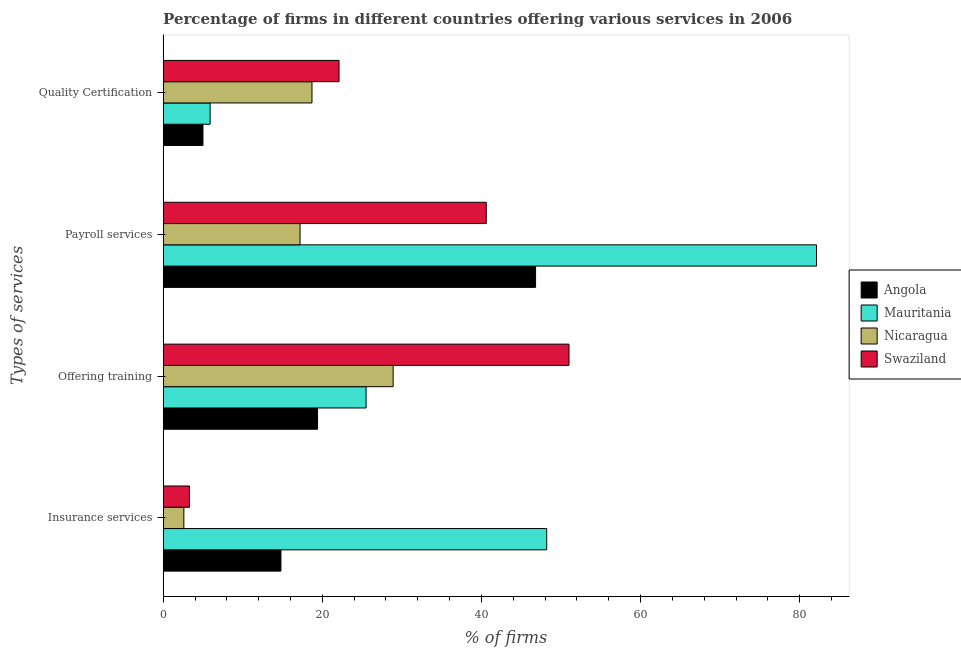How many different coloured bars are there?
Offer a terse response. 4. How many groups of bars are there?
Your answer should be very brief. 4. Are the number of bars per tick equal to the number of legend labels?
Provide a short and direct response. Yes. Are the number of bars on each tick of the Y-axis equal?
Provide a succinct answer. Yes. What is the label of the 1st group of bars from the top?
Keep it short and to the point. Quality Certification. What is the percentage of firms offering quality certification in Nicaragua?
Your answer should be very brief. 18.7. Across all countries, what is the maximum percentage of firms offering quality certification?
Provide a short and direct response. 22.1. In which country was the percentage of firms offering quality certification maximum?
Provide a short and direct response. Swaziland. In which country was the percentage of firms offering insurance services minimum?
Keep it short and to the point. Nicaragua. What is the total percentage of firms offering training in the graph?
Your response must be concise. 124.8. What is the difference between the percentage of firms offering payroll services in Angola and that in Nicaragua?
Your answer should be compact. 29.6. What is the difference between the percentage of firms offering training in Swaziland and the percentage of firms offering insurance services in Nicaragua?
Offer a terse response. 48.4. What is the average percentage of firms offering payroll services per country?
Provide a succinct answer. 46.67. What is the difference between the percentage of firms offering quality certification and percentage of firms offering payroll services in Angola?
Your answer should be very brief. -41.8. In how many countries, is the percentage of firms offering payroll services greater than 48 %?
Offer a very short reply. 1. What is the ratio of the percentage of firms offering payroll services in Mauritania to that in Nicaragua?
Offer a terse response. 4.77. What is the difference between the highest and the second highest percentage of firms offering training?
Offer a terse response. 22.1. In how many countries, is the percentage of firms offering payroll services greater than the average percentage of firms offering payroll services taken over all countries?
Provide a succinct answer. 2. Is the sum of the percentage of firms offering training in Mauritania and Angola greater than the maximum percentage of firms offering payroll services across all countries?
Provide a succinct answer. No. Is it the case that in every country, the sum of the percentage of firms offering payroll services and percentage of firms offering insurance services is greater than the sum of percentage of firms offering quality certification and percentage of firms offering training?
Offer a very short reply. No. What does the 1st bar from the top in Payroll services represents?
Ensure brevity in your answer.  Swaziland. What does the 4th bar from the bottom in Offering training represents?
Offer a very short reply. Swaziland. How many bars are there?
Provide a short and direct response. 16. How many countries are there in the graph?
Ensure brevity in your answer.  4. What is the difference between two consecutive major ticks on the X-axis?
Give a very brief answer. 20. Are the values on the major ticks of X-axis written in scientific E-notation?
Make the answer very short. No. Does the graph contain grids?
Your answer should be very brief. No. How many legend labels are there?
Provide a short and direct response. 4. How are the legend labels stacked?
Give a very brief answer. Vertical. What is the title of the graph?
Make the answer very short. Percentage of firms in different countries offering various services in 2006. Does "Croatia" appear as one of the legend labels in the graph?
Your answer should be compact. No. What is the label or title of the X-axis?
Your answer should be compact. % of firms. What is the label or title of the Y-axis?
Provide a short and direct response. Types of services. What is the % of firms of Mauritania in Insurance services?
Keep it short and to the point. 48.2. What is the % of firms in Swaziland in Insurance services?
Make the answer very short. 3.3. What is the % of firms of Angola in Offering training?
Give a very brief answer. 19.4. What is the % of firms in Nicaragua in Offering training?
Your answer should be very brief. 28.9. What is the % of firms in Swaziland in Offering training?
Provide a short and direct response. 51. What is the % of firms in Angola in Payroll services?
Offer a very short reply. 46.8. What is the % of firms in Mauritania in Payroll services?
Your answer should be compact. 82.1. What is the % of firms in Nicaragua in Payroll services?
Make the answer very short. 17.2. What is the % of firms of Swaziland in Payroll services?
Keep it short and to the point. 40.6. What is the % of firms of Angola in Quality Certification?
Your answer should be compact. 5. What is the % of firms in Mauritania in Quality Certification?
Offer a very short reply. 5.9. What is the % of firms of Nicaragua in Quality Certification?
Your answer should be very brief. 18.7. What is the % of firms of Swaziland in Quality Certification?
Keep it short and to the point. 22.1. Across all Types of services, what is the maximum % of firms in Angola?
Your answer should be very brief. 46.8. Across all Types of services, what is the maximum % of firms in Mauritania?
Your answer should be very brief. 82.1. Across all Types of services, what is the maximum % of firms in Nicaragua?
Offer a very short reply. 28.9. Across all Types of services, what is the minimum % of firms of Angola?
Ensure brevity in your answer.  5. Across all Types of services, what is the minimum % of firms in Nicaragua?
Offer a terse response. 2.6. Across all Types of services, what is the minimum % of firms in Swaziland?
Provide a succinct answer. 3.3. What is the total % of firms of Angola in the graph?
Give a very brief answer. 86. What is the total % of firms in Mauritania in the graph?
Give a very brief answer. 161.7. What is the total % of firms of Nicaragua in the graph?
Keep it short and to the point. 67.4. What is the total % of firms of Swaziland in the graph?
Give a very brief answer. 117. What is the difference between the % of firms in Angola in Insurance services and that in Offering training?
Your answer should be compact. -4.6. What is the difference between the % of firms of Mauritania in Insurance services and that in Offering training?
Your answer should be compact. 22.7. What is the difference between the % of firms in Nicaragua in Insurance services and that in Offering training?
Give a very brief answer. -26.3. What is the difference between the % of firms in Swaziland in Insurance services and that in Offering training?
Provide a short and direct response. -47.7. What is the difference between the % of firms in Angola in Insurance services and that in Payroll services?
Your answer should be very brief. -32. What is the difference between the % of firms in Mauritania in Insurance services and that in Payroll services?
Provide a short and direct response. -33.9. What is the difference between the % of firms in Nicaragua in Insurance services and that in Payroll services?
Your answer should be compact. -14.6. What is the difference between the % of firms of Swaziland in Insurance services and that in Payroll services?
Provide a succinct answer. -37.3. What is the difference between the % of firms in Angola in Insurance services and that in Quality Certification?
Ensure brevity in your answer.  9.8. What is the difference between the % of firms of Mauritania in Insurance services and that in Quality Certification?
Your answer should be compact. 42.3. What is the difference between the % of firms of Nicaragua in Insurance services and that in Quality Certification?
Offer a very short reply. -16.1. What is the difference between the % of firms in Swaziland in Insurance services and that in Quality Certification?
Offer a terse response. -18.8. What is the difference between the % of firms of Angola in Offering training and that in Payroll services?
Offer a very short reply. -27.4. What is the difference between the % of firms of Mauritania in Offering training and that in Payroll services?
Your response must be concise. -56.6. What is the difference between the % of firms in Swaziland in Offering training and that in Payroll services?
Your response must be concise. 10.4. What is the difference between the % of firms of Angola in Offering training and that in Quality Certification?
Offer a terse response. 14.4. What is the difference between the % of firms in Mauritania in Offering training and that in Quality Certification?
Offer a very short reply. 19.6. What is the difference between the % of firms of Nicaragua in Offering training and that in Quality Certification?
Make the answer very short. 10.2. What is the difference between the % of firms of Swaziland in Offering training and that in Quality Certification?
Your answer should be compact. 28.9. What is the difference between the % of firms in Angola in Payroll services and that in Quality Certification?
Your response must be concise. 41.8. What is the difference between the % of firms of Mauritania in Payroll services and that in Quality Certification?
Provide a succinct answer. 76.2. What is the difference between the % of firms of Nicaragua in Payroll services and that in Quality Certification?
Offer a terse response. -1.5. What is the difference between the % of firms of Angola in Insurance services and the % of firms of Mauritania in Offering training?
Offer a terse response. -10.7. What is the difference between the % of firms in Angola in Insurance services and the % of firms in Nicaragua in Offering training?
Keep it short and to the point. -14.1. What is the difference between the % of firms in Angola in Insurance services and the % of firms in Swaziland in Offering training?
Your response must be concise. -36.2. What is the difference between the % of firms in Mauritania in Insurance services and the % of firms in Nicaragua in Offering training?
Your answer should be compact. 19.3. What is the difference between the % of firms in Nicaragua in Insurance services and the % of firms in Swaziland in Offering training?
Ensure brevity in your answer.  -48.4. What is the difference between the % of firms in Angola in Insurance services and the % of firms in Mauritania in Payroll services?
Offer a very short reply. -67.3. What is the difference between the % of firms of Angola in Insurance services and the % of firms of Swaziland in Payroll services?
Offer a very short reply. -25.8. What is the difference between the % of firms in Mauritania in Insurance services and the % of firms in Swaziland in Payroll services?
Your response must be concise. 7.6. What is the difference between the % of firms in Nicaragua in Insurance services and the % of firms in Swaziland in Payroll services?
Ensure brevity in your answer.  -38. What is the difference between the % of firms of Angola in Insurance services and the % of firms of Nicaragua in Quality Certification?
Provide a succinct answer. -3.9. What is the difference between the % of firms of Angola in Insurance services and the % of firms of Swaziland in Quality Certification?
Your answer should be compact. -7.3. What is the difference between the % of firms in Mauritania in Insurance services and the % of firms in Nicaragua in Quality Certification?
Provide a short and direct response. 29.5. What is the difference between the % of firms in Mauritania in Insurance services and the % of firms in Swaziland in Quality Certification?
Offer a terse response. 26.1. What is the difference between the % of firms in Nicaragua in Insurance services and the % of firms in Swaziland in Quality Certification?
Your answer should be very brief. -19.5. What is the difference between the % of firms in Angola in Offering training and the % of firms in Mauritania in Payroll services?
Your answer should be very brief. -62.7. What is the difference between the % of firms in Angola in Offering training and the % of firms in Nicaragua in Payroll services?
Make the answer very short. 2.2. What is the difference between the % of firms in Angola in Offering training and the % of firms in Swaziland in Payroll services?
Provide a succinct answer. -21.2. What is the difference between the % of firms in Mauritania in Offering training and the % of firms in Swaziland in Payroll services?
Offer a very short reply. -15.1. What is the difference between the % of firms in Angola in Offering training and the % of firms in Nicaragua in Quality Certification?
Offer a very short reply. 0.7. What is the difference between the % of firms of Angola in Offering training and the % of firms of Swaziland in Quality Certification?
Your response must be concise. -2.7. What is the difference between the % of firms of Mauritania in Offering training and the % of firms of Swaziland in Quality Certification?
Provide a short and direct response. 3.4. What is the difference between the % of firms of Angola in Payroll services and the % of firms of Mauritania in Quality Certification?
Provide a short and direct response. 40.9. What is the difference between the % of firms in Angola in Payroll services and the % of firms in Nicaragua in Quality Certification?
Offer a terse response. 28.1. What is the difference between the % of firms of Angola in Payroll services and the % of firms of Swaziland in Quality Certification?
Make the answer very short. 24.7. What is the difference between the % of firms in Mauritania in Payroll services and the % of firms in Nicaragua in Quality Certification?
Provide a short and direct response. 63.4. What is the difference between the % of firms of Mauritania in Payroll services and the % of firms of Swaziland in Quality Certification?
Your response must be concise. 60. What is the average % of firms of Mauritania per Types of services?
Make the answer very short. 40.42. What is the average % of firms of Nicaragua per Types of services?
Offer a terse response. 16.85. What is the average % of firms in Swaziland per Types of services?
Your answer should be very brief. 29.25. What is the difference between the % of firms of Angola and % of firms of Mauritania in Insurance services?
Offer a terse response. -33.4. What is the difference between the % of firms in Angola and % of firms in Swaziland in Insurance services?
Make the answer very short. 11.5. What is the difference between the % of firms in Mauritania and % of firms in Nicaragua in Insurance services?
Offer a terse response. 45.6. What is the difference between the % of firms of Mauritania and % of firms of Swaziland in Insurance services?
Offer a very short reply. 44.9. What is the difference between the % of firms of Angola and % of firms of Mauritania in Offering training?
Offer a terse response. -6.1. What is the difference between the % of firms of Angola and % of firms of Nicaragua in Offering training?
Provide a succinct answer. -9.5. What is the difference between the % of firms in Angola and % of firms in Swaziland in Offering training?
Your answer should be very brief. -31.6. What is the difference between the % of firms of Mauritania and % of firms of Nicaragua in Offering training?
Ensure brevity in your answer.  -3.4. What is the difference between the % of firms in Mauritania and % of firms in Swaziland in Offering training?
Provide a succinct answer. -25.5. What is the difference between the % of firms of Nicaragua and % of firms of Swaziland in Offering training?
Keep it short and to the point. -22.1. What is the difference between the % of firms in Angola and % of firms in Mauritania in Payroll services?
Your response must be concise. -35.3. What is the difference between the % of firms in Angola and % of firms in Nicaragua in Payroll services?
Your response must be concise. 29.6. What is the difference between the % of firms in Angola and % of firms in Swaziland in Payroll services?
Offer a very short reply. 6.2. What is the difference between the % of firms in Mauritania and % of firms in Nicaragua in Payroll services?
Ensure brevity in your answer.  64.9. What is the difference between the % of firms of Mauritania and % of firms of Swaziland in Payroll services?
Your answer should be compact. 41.5. What is the difference between the % of firms of Nicaragua and % of firms of Swaziland in Payroll services?
Provide a short and direct response. -23.4. What is the difference between the % of firms in Angola and % of firms in Nicaragua in Quality Certification?
Provide a succinct answer. -13.7. What is the difference between the % of firms in Angola and % of firms in Swaziland in Quality Certification?
Provide a succinct answer. -17.1. What is the difference between the % of firms in Mauritania and % of firms in Nicaragua in Quality Certification?
Ensure brevity in your answer.  -12.8. What is the difference between the % of firms of Mauritania and % of firms of Swaziland in Quality Certification?
Your answer should be compact. -16.2. What is the ratio of the % of firms in Angola in Insurance services to that in Offering training?
Make the answer very short. 0.76. What is the ratio of the % of firms of Mauritania in Insurance services to that in Offering training?
Ensure brevity in your answer.  1.89. What is the ratio of the % of firms in Nicaragua in Insurance services to that in Offering training?
Provide a short and direct response. 0.09. What is the ratio of the % of firms of Swaziland in Insurance services to that in Offering training?
Your response must be concise. 0.06. What is the ratio of the % of firms of Angola in Insurance services to that in Payroll services?
Your response must be concise. 0.32. What is the ratio of the % of firms of Mauritania in Insurance services to that in Payroll services?
Provide a short and direct response. 0.59. What is the ratio of the % of firms in Nicaragua in Insurance services to that in Payroll services?
Give a very brief answer. 0.15. What is the ratio of the % of firms in Swaziland in Insurance services to that in Payroll services?
Ensure brevity in your answer.  0.08. What is the ratio of the % of firms in Angola in Insurance services to that in Quality Certification?
Provide a succinct answer. 2.96. What is the ratio of the % of firms of Mauritania in Insurance services to that in Quality Certification?
Your answer should be compact. 8.17. What is the ratio of the % of firms of Nicaragua in Insurance services to that in Quality Certification?
Your answer should be very brief. 0.14. What is the ratio of the % of firms in Swaziland in Insurance services to that in Quality Certification?
Offer a terse response. 0.15. What is the ratio of the % of firms in Angola in Offering training to that in Payroll services?
Offer a very short reply. 0.41. What is the ratio of the % of firms of Mauritania in Offering training to that in Payroll services?
Make the answer very short. 0.31. What is the ratio of the % of firms in Nicaragua in Offering training to that in Payroll services?
Offer a terse response. 1.68. What is the ratio of the % of firms in Swaziland in Offering training to that in Payroll services?
Make the answer very short. 1.26. What is the ratio of the % of firms of Angola in Offering training to that in Quality Certification?
Give a very brief answer. 3.88. What is the ratio of the % of firms in Mauritania in Offering training to that in Quality Certification?
Make the answer very short. 4.32. What is the ratio of the % of firms of Nicaragua in Offering training to that in Quality Certification?
Your response must be concise. 1.55. What is the ratio of the % of firms in Swaziland in Offering training to that in Quality Certification?
Your response must be concise. 2.31. What is the ratio of the % of firms in Angola in Payroll services to that in Quality Certification?
Give a very brief answer. 9.36. What is the ratio of the % of firms of Mauritania in Payroll services to that in Quality Certification?
Make the answer very short. 13.92. What is the ratio of the % of firms in Nicaragua in Payroll services to that in Quality Certification?
Provide a succinct answer. 0.92. What is the ratio of the % of firms of Swaziland in Payroll services to that in Quality Certification?
Your answer should be very brief. 1.84. What is the difference between the highest and the second highest % of firms of Angola?
Offer a terse response. 27.4. What is the difference between the highest and the second highest % of firms of Mauritania?
Offer a terse response. 33.9. What is the difference between the highest and the second highest % of firms of Nicaragua?
Offer a terse response. 10.2. What is the difference between the highest and the second highest % of firms of Swaziland?
Ensure brevity in your answer.  10.4. What is the difference between the highest and the lowest % of firms in Angola?
Make the answer very short. 41.8. What is the difference between the highest and the lowest % of firms in Mauritania?
Ensure brevity in your answer.  76.2. What is the difference between the highest and the lowest % of firms in Nicaragua?
Provide a short and direct response. 26.3. What is the difference between the highest and the lowest % of firms in Swaziland?
Offer a very short reply. 47.7. 